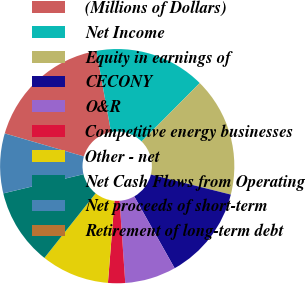<chart> <loc_0><loc_0><loc_500><loc_500><pie_chart><fcel>(Millions of Dollars)<fcel>Net Income<fcel>Equity in earnings of<fcel>CECONY<fcel>O&R<fcel>Competitive energy businesses<fcel>Other - net<fcel>Net Cash Flows from Operating<fcel>Net proceeds of short-term<fcel>Retirement of long-term debt<nl><fcel>17.64%<fcel>15.29%<fcel>16.46%<fcel>12.94%<fcel>7.06%<fcel>2.36%<fcel>9.41%<fcel>10.59%<fcel>8.24%<fcel>0.01%<nl></chart> 